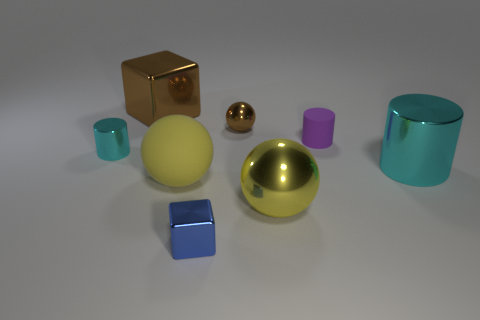What is the color of the rubber cylinder?
Offer a very short reply. Purple. Is the purple cylinder the same size as the blue metal cube?
Make the answer very short. Yes. Are the blue block and the cube behind the small blue thing made of the same material?
Keep it short and to the point. Yes. There is a shiny cylinder to the left of the small rubber object; does it have the same color as the large metal cylinder?
Ensure brevity in your answer.  Yes. How many cyan cylinders are on the left side of the big brown object and right of the tiny purple rubber thing?
Your answer should be very brief. 0. How many other objects are the same material as the brown sphere?
Provide a short and direct response. 5. Is the large thing behind the small purple thing made of the same material as the purple object?
Ensure brevity in your answer.  No. There is a cyan metal thing left of the small cylinder behind the tiny cylinder that is left of the matte cylinder; what is its size?
Your answer should be very brief. Small. How many other things are the same color as the big rubber thing?
Your answer should be compact. 1. What is the shape of the matte object that is the same size as the blue shiny cube?
Your answer should be compact. Cylinder. 